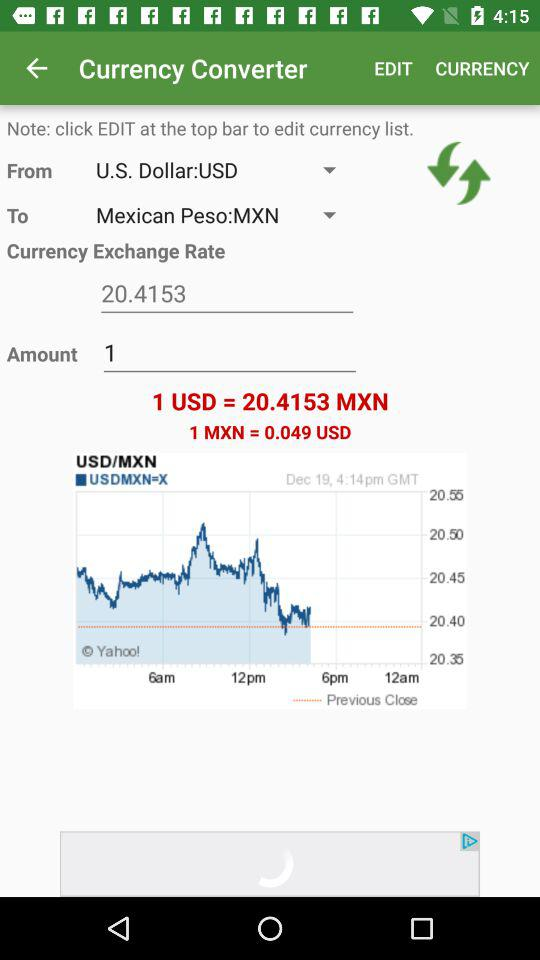What is the mentioned date? The mentioned date is December 19. 